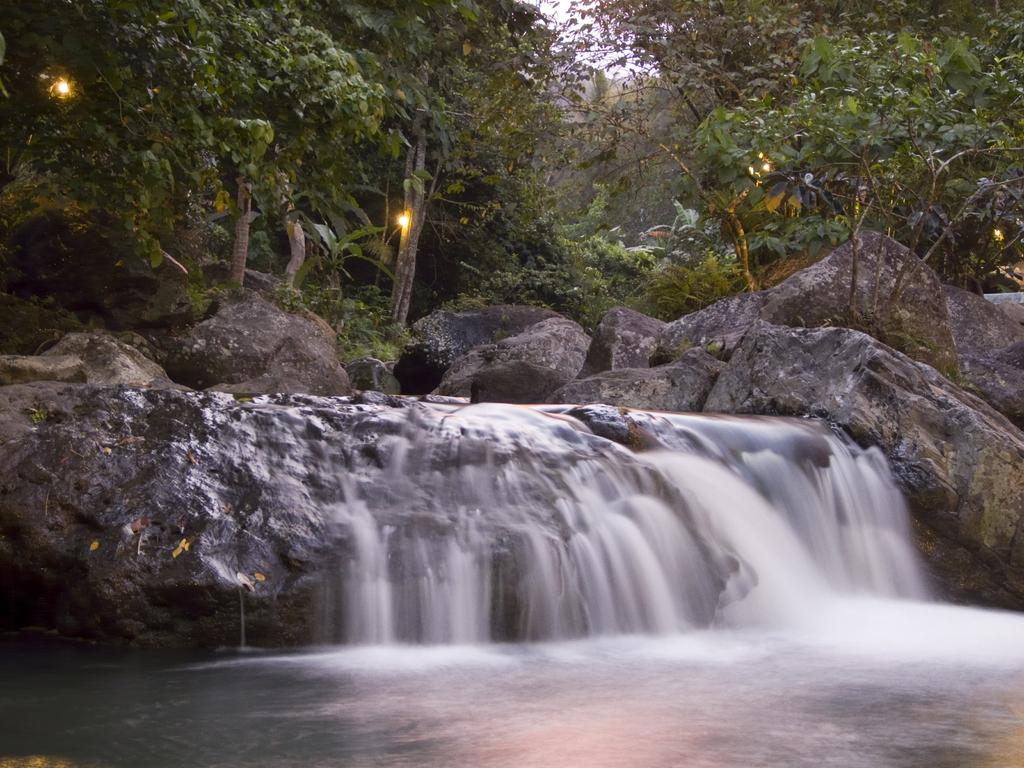What natural feature is the main subject of the image? There is a waterfall in the image. What other elements can be seen in the image? There are rocks and trees in the image. Is there a beggar asking for money near the waterfall in the image? No, there is no beggar present in the image. What thoughts or ideas are depicted in the image? The image does not show any thoughts or ideas; it is a visual representation of a waterfall, rocks, and trees. 